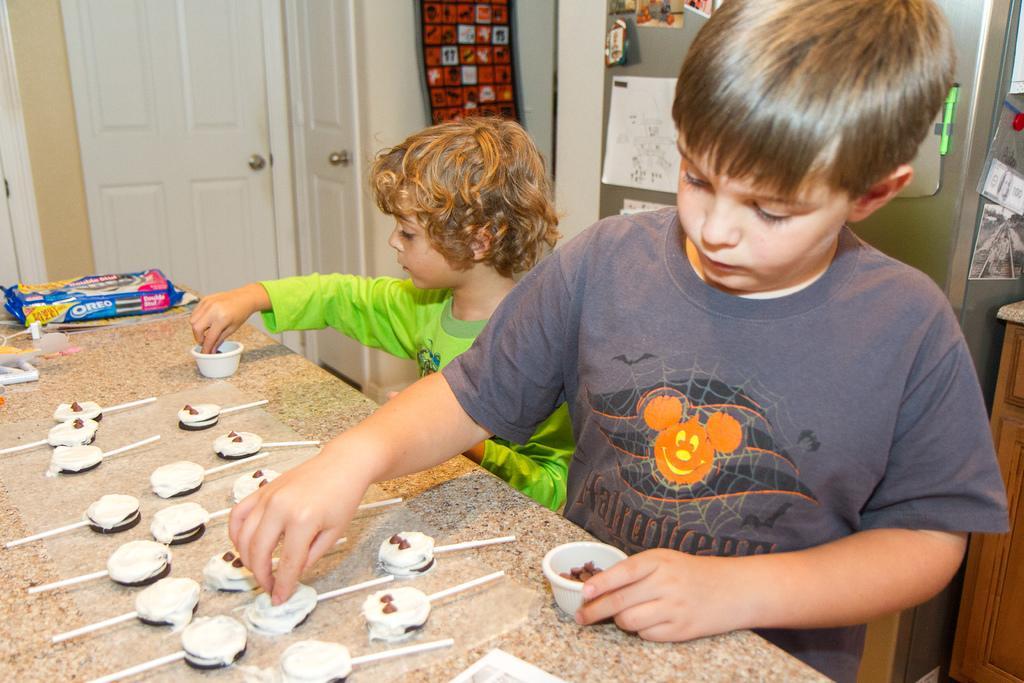Describe this image in one or two sentences. In this picture I can see a table in front on which there are white and brown color things and I see a thing which is colorful and I see something is written and I see 2 boys who are standing. In the background I see a fridge on which there are few things and I see the doors on the left side of the image. 